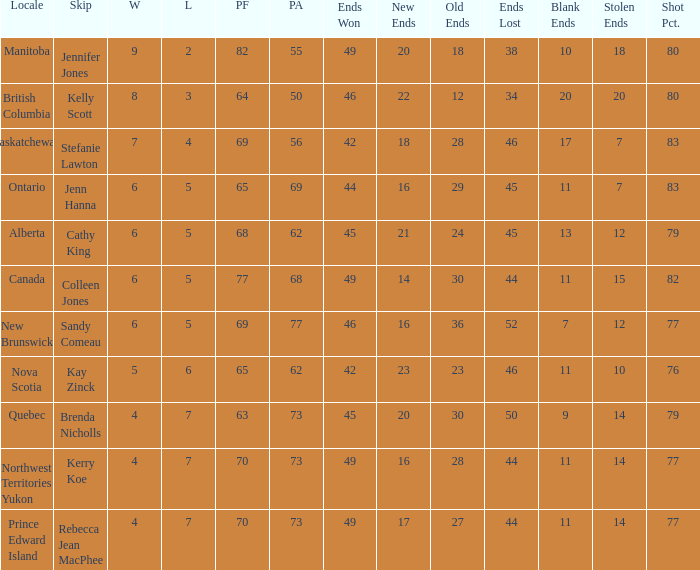Would you mind parsing the complete table? {'header': ['Locale', 'Skip', 'W', 'L', 'PF', 'PA', 'Ends Won', 'New Ends', 'Old Ends', 'Ends Lost', 'Blank Ends', 'Stolen Ends', 'Shot Pct.'], 'rows': [['Manitoba', 'Jennifer Jones', '9', '2', '82', '55', '49', '20', '18', '38', '10', '18', '80'], ['British Columbia', 'Kelly Scott', '8', '3', '64', '50', '46', '22', '12', '34', '20', '20', '80'], ['Saskatchewan', 'Stefanie Lawton', '7', '4', '69', '56', '42', '18', '28', '46', '17', '7', '83'], ['Ontario', 'Jenn Hanna', '6', '5', '65', '69', '44', '16', '29', '45', '11', '7', '83'], ['Alberta', 'Cathy King', '6', '5', '68', '62', '45', '21', '24', '45', '13', '12', '79'], ['Canada', 'Colleen Jones', '6', '5', '77', '68', '49', '14', '30', '44', '11', '15', '82'], ['New Brunswick', 'Sandy Comeau', '6', '5', '69', '77', '46', '16', '36', '52', '7', '12', '77'], ['Nova Scotia', 'Kay Zinck', '5', '6', '65', '62', '42', '23', '23', '46', '11', '10', '76'], ['Quebec', 'Brenda Nicholls', '4', '7', '63', '73', '45', '20', '30', '50', '9', '14', '79'], ['Northwest Territories Yukon', 'Kerry Koe', '4', '7', '70', '73', '49', '16', '28', '44', '11', '14', '77'], ['Prince Edward Island', 'Rebecca Jean MacPhee', '4', '7', '70', '73', '49', '17', '27', '44', '11', '14', '77']]} What is the minimum PA when ends lost is 45? 62.0. 